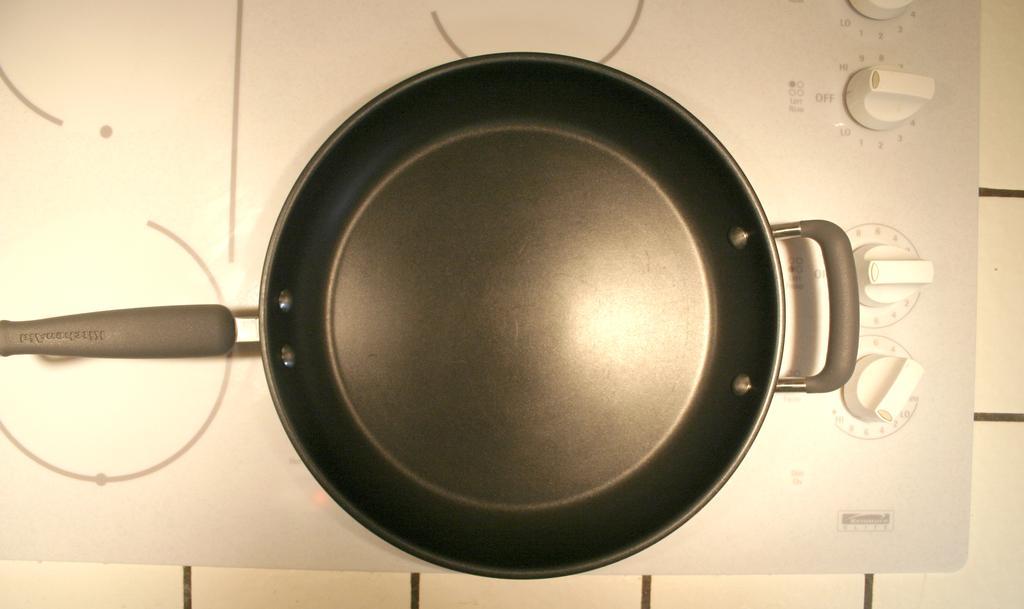Can you describe this image briefly? As we can see in the image there is an induction stove and hand tool cement bowl. 